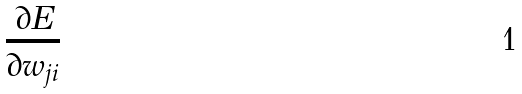Convert formula to latex. <formula><loc_0><loc_0><loc_500><loc_500>\frac { \partial E } { \partial w _ { j i } }</formula> 